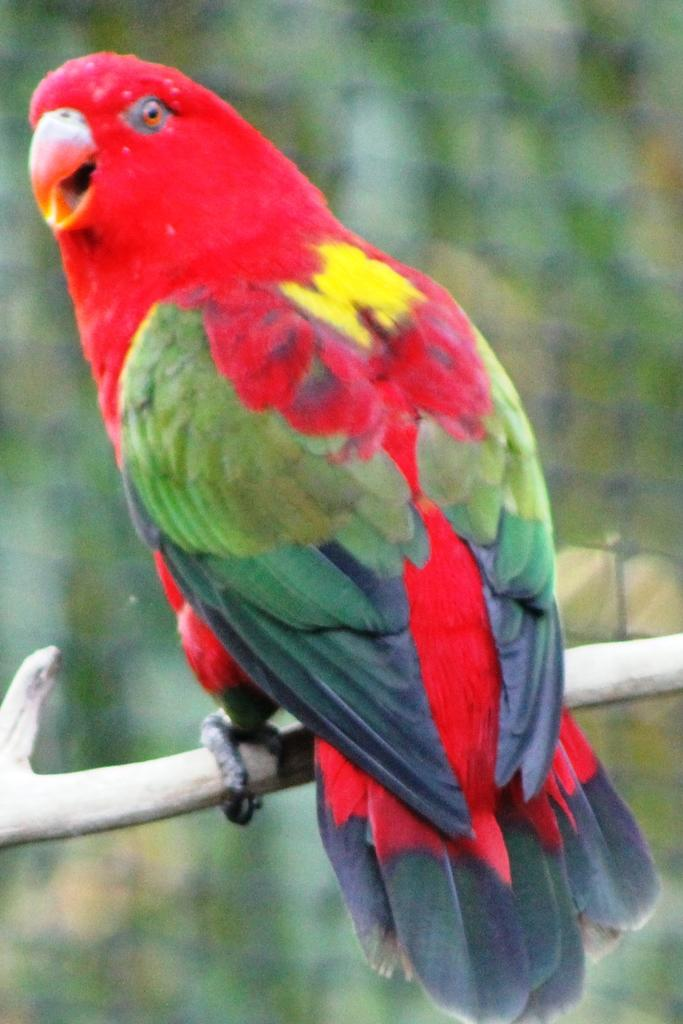What is the main subject in the foreground of the image? There is a bird in the foreground of the image. What can be seen in the background of the image? There is a net and plants in the background of the image. What color is the bird's hair in the image? Birds do not have hair, so this detail cannot be determined from the image. 